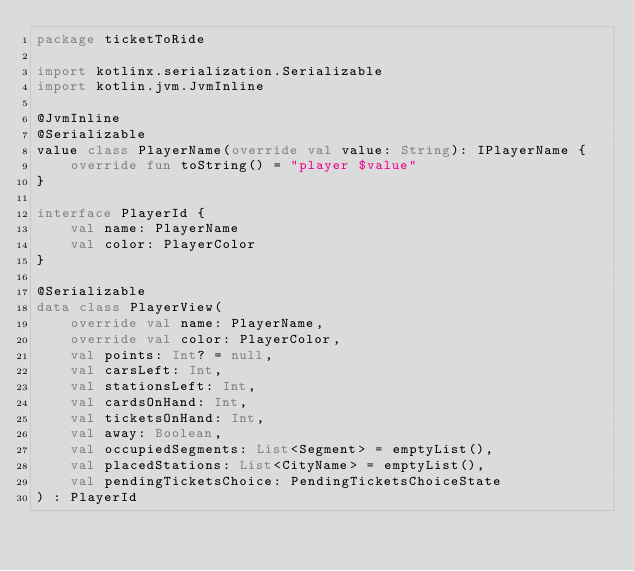<code> <loc_0><loc_0><loc_500><loc_500><_Kotlin_>package ticketToRide

import kotlinx.serialization.Serializable
import kotlin.jvm.JvmInline

@JvmInline
@Serializable
value class PlayerName(override val value: String): IPlayerName {
    override fun toString() = "player $value"
}

interface PlayerId {
    val name: PlayerName
    val color: PlayerColor
}

@Serializable
data class PlayerView(
    override val name: PlayerName,
    override val color: PlayerColor,
    val points: Int? = null,
    val carsLeft: Int,
    val stationsLeft: Int,
    val cardsOnHand: Int,
    val ticketsOnHand: Int,
    val away: Boolean,
    val occupiedSegments: List<Segment> = emptyList(),
    val placedStations: List<CityName> = emptyList(),
    val pendingTicketsChoice: PendingTicketsChoiceState
) : PlayerId
</code> 